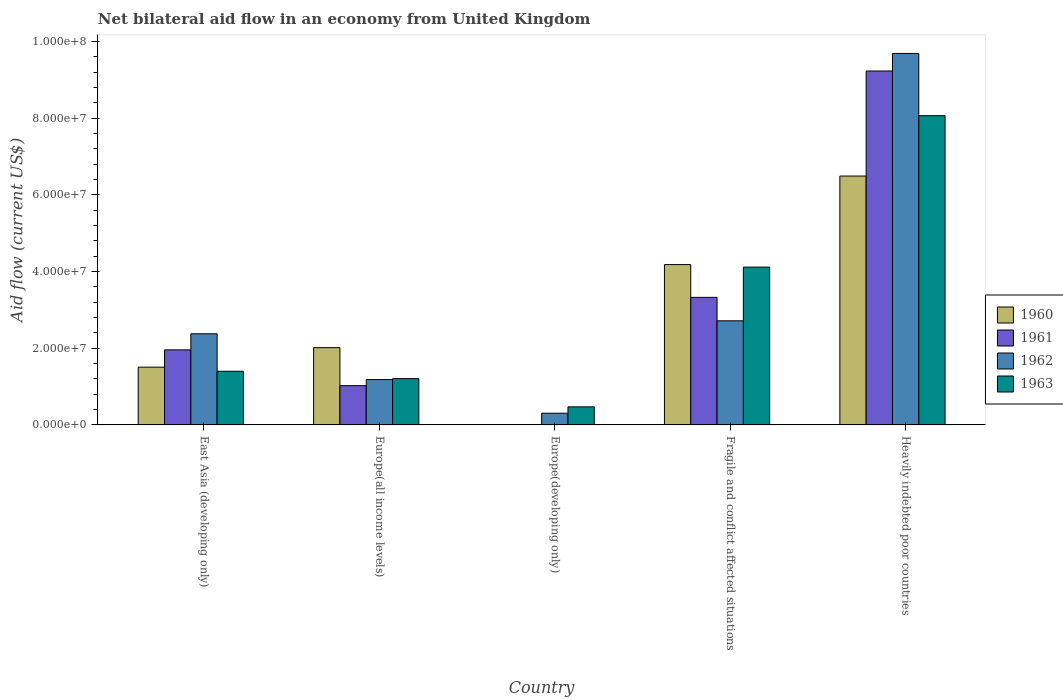How many groups of bars are there?
Your response must be concise. 5. Are the number of bars per tick equal to the number of legend labels?
Offer a terse response. No. Are the number of bars on each tick of the X-axis equal?
Provide a succinct answer. No. How many bars are there on the 1st tick from the left?
Offer a terse response. 4. How many bars are there on the 2nd tick from the right?
Provide a succinct answer. 4. What is the label of the 5th group of bars from the left?
Provide a short and direct response. Heavily indebted poor countries. In how many cases, is the number of bars for a given country not equal to the number of legend labels?
Your answer should be very brief. 1. What is the net bilateral aid flow in 1961 in Europe(developing only)?
Your answer should be compact. 0. Across all countries, what is the maximum net bilateral aid flow in 1962?
Keep it short and to the point. 9.69e+07. Across all countries, what is the minimum net bilateral aid flow in 1963?
Provide a succinct answer. 4.71e+06. In which country was the net bilateral aid flow in 1962 maximum?
Provide a short and direct response. Heavily indebted poor countries. What is the total net bilateral aid flow in 1962 in the graph?
Give a very brief answer. 1.63e+08. What is the difference between the net bilateral aid flow in 1963 in Europe(all income levels) and that in Heavily indebted poor countries?
Make the answer very short. -6.86e+07. What is the difference between the net bilateral aid flow in 1963 in East Asia (developing only) and the net bilateral aid flow in 1960 in Europe(developing only)?
Offer a very short reply. 1.40e+07. What is the average net bilateral aid flow in 1961 per country?
Your response must be concise. 3.11e+07. What is the difference between the net bilateral aid flow of/in 1961 and net bilateral aid flow of/in 1960 in East Asia (developing only)?
Your answer should be very brief. 4.51e+06. In how many countries, is the net bilateral aid flow in 1960 greater than 76000000 US$?
Offer a very short reply. 0. What is the ratio of the net bilateral aid flow in 1962 in East Asia (developing only) to that in Europe(all income levels)?
Your answer should be very brief. 2.01. What is the difference between the highest and the second highest net bilateral aid flow in 1962?
Offer a terse response. 7.31e+07. What is the difference between the highest and the lowest net bilateral aid flow in 1962?
Make the answer very short. 9.38e+07. In how many countries, is the net bilateral aid flow in 1960 greater than the average net bilateral aid flow in 1960 taken over all countries?
Provide a short and direct response. 2. Is it the case that in every country, the sum of the net bilateral aid flow in 1963 and net bilateral aid flow in 1962 is greater than the sum of net bilateral aid flow in 1961 and net bilateral aid flow in 1960?
Your response must be concise. No. How many countries are there in the graph?
Provide a short and direct response. 5. Are the values on the major ticks of Y-axis written in scientific E-notation?
Make the answer very short. Yes. Does the graph contain grids?
Make the answer very short. No. Where does the legend appear in the graph?
Give a very brief answer. Center right. What is the title of the graph?
Ensure brevity in your answer.  Net bilateral aid flow in an economy from United Kingdom. Does "1999" appear as one of the legend labels in the graph?
Offer a terse response. No. What is the Aid flow (current US$) in 1960 in East Asia (developing only)?
Keep it short and to the point. 1.51e+07. What is the Aid flow (current US$) of 1961 in East Asia (developing only)?
Keep it short and to the point. 1.96e+07. What is the Aid flow (current US$) in 1962 in East Asia (developing only)?
Provide a succinct answer. 2.38e+07. What is the Aid flow (current US$) in 1963 in East Asia (developing only)?
Your response must be concise. 1.40e+07. What is the Aid flow (current US$) of 1960 in Europe(all income levels)?
Keep it short and to the point. 2.02e+07. What is the Aid flow (current US$) of 1961 in Europe(all income levels)?
Make the answer very short. 1.02e+07. What is the Aid flow (current US$) in 1962 in Europe(all income levels)?
Provide a succinct answer. 1.18e+07. What is the Aid flow (current US$) in 1963 in Europe(all income levels)?
Offer a terse response. 1.21e+07. What is the Aid flow (current US$) in 1960 in Europe(developing only)?
Your answer should be very brief. 0. What is the Aid flow (current US$) of 1961 in Europe(developing only)?
Your response must be concise. 0. What is the Aid flow (current US$) in 1962 in Europe(developing only)?
Make the answer very short. 3.05e+06. What is the Aid flow (current US$) of 1963 in Europe(developing only)?
Ensure brevity in your answer.  4.71e+06. What is the Aid flow (current US$) in 1960 in Fragile and conflict affected situations?
Keep it short and to the point. 4.18e+07. What is the Aid flow (current US$) in 1961 in Fragile and conflict affected situations?
Keep it short and to the point. 3.33e+07. What is the Aid flow (current US$) in 1962 in Fragile and conflict affected situations?
Make the answer very short. 2.72e+07. What is the Aid flow (current US$) in 1963 in Fragile and conflict affected situations?
Offer a very short reply. 4.12e+07. What is the Aid flow (current US$) in 1960 in Heavily indebted poor countries?
Keep it short and to the point. 6.49e+07. What is the Aid flow (current US$) of 1961 in Heavily indebted poor countries?
Offer a terse response. 9.23e+07. What is the Aid flow (current US$) of 1962 in Heavily indebted poor countries?
Ensure brevity in your answer.  9.69e+07. What is the Aid flow (current US$) in 1963 in Heavily indebted poor countries?
Your response must be concise. 8.06e+07. Across all countries, what is the maximum Aid flow (current US$) of 1960?
Offer a very short reply. 6.49e+07. Across all countries, what is the maximum Aid flow (current US$) of 1961?
Provide a succinct answer. 9.23e+07. Across all countries, what is the maximum Aid flow (current US$) of 1962?
Your answer should be very brief. 9.69e+07. Across all countries, what is the maximum Aid flow (current US$) of 1963?
Offer a terse response. 8.06e+07. Across all countries, what is the minimum Aid flow (current US$) in 1962?
Your answer should be very brief. 3.05e+06. Across all countries, what is the minimum Aid flow (current US$) in 1963?
Keep it short and to the point. 4.71e+06. What is the total Aid flow (current US$) of 1960 in the graph?
Provide a short and direct response. 1.42e+08. What is the total Aid flow (current US$) of 1961 in the graph?
Ensure brevity in your answer.  1.55e+08. What is the total Aid flow (current US$) of 1962 in the graph?
Give a very brief answer. 1.63e+08. What is the total Aid flow (current US$) of 1963 in the graph?
Offer a terse response. 1.53e+08. What is the difference between the Aid flow (current US$) in 1960 in East Asia (developing only) and that in Europe(all income levels)?
Provide a succinct answer. -5.09e+06. What is the difference between the Aid flow (current US$) of 1961 in East Asia (developing only) and that in Europe(all income levels)?
Keep it short and to the point. 9.33e+06. What is the difference between the Aid flow (current US$) in 1962 in East Asia (developing only) and that in Europe(all income levels)?
Offer a very short reply. 1.19e+07. What is the difference between the Aid flow (current US$) in 1963 in East Asia (developing only) and that in Europe(all income levels)?
Make the answer very short. 1.92e+06. What is the difference between the Aid flow (current US$) in 1962 in East Asia (developing only) and that in Europe(developing only)?
Your response must be concise. 2.07e+07. What is the difference between the Aid flow (current US$) in 1963 in East Asia (developing only) and that in Europe(developing only)?
Your answer should be very brief. 9.28e+06. What is the difference between the Aid flow (current US$) of 1960 in East Asia (developing only) and that in Fragile and conflict affected situations?
Keep it short and to the point. -2.68e+07. What is the difference between the Aid flow (current US$) in 1961 in East Asia (developing only) and that in Fragile and conflict affected situations?
Provide a succinct answer. -1.37e+07. What is the difference between the Aid flow (current US$) of 1962 in East Asia (developing only) and that in Fragile and conflict affected situations?
Your answer should be very brief. -3.39e+06. What is the difference between the Aid flow (current US$) in 1963 in East Asia (developing only) and that in Fragile and conflict affected situations?
Provide a succinct answer. -2.72e+07. What is the difference between the Aid flow (current US$) of 1960 in East Asia (developing only) and that in Heavily indebted poor countries?
Your answer should be compact. -4.98e+07. What is the difference between the Aid flow (current US$) of 1961 in East Asia (developing only) and that in Heavily indebted poor countries?
Provide a succinct answer. -7.27e+07. What is the difference between the Aid flow (current US$) in 1962 in East Asia (developing only) and that in Heavily indebted poor countries?
Your answer should be very brief. -7.31e+07. What is the difference between the Aid flow (current US$) in 1963 in East Asia (developing only) and that in Heavily indebted poor countries?
Provide a succinct answer. -6.66e+07. What is the difference between the Aid flow (current US$) in 1962 in Europe(all income levels) and that in Europe(developing only)?
Offer a very short reply. 8.77e+06. What is the difference between the Aid flow (current US$) of 1963 in Europe(all income levels) and that in Europe(developing only)?
Ensure brevity in your answer.  7.36e+06. What is the difference between the Aid flow (current US$) of 1960 in Europe(all income levels) and that in Fragile and conflict affected situations?
Offer a very short reply. -2.17e+07. What is the difference between the Aid flow (current US$) in 1961 in Europe(all income levels) and that in Fragile and conflict affected situations?
Your response must be concise. -2.30e+07. What is the difference between the Aid flow (current US$) in 1962 in Europe(all income levels) and that in Fragile and conflict affected situations?
Offer a very short reply. -1.53e+07. What is the difference between the Aid flow (current US$) in 1963 in Europe(all income levels) and that in Fragile and conflict affected situations?
Provide a short and direct response. -2.91e+07. What is the difference between the Aid flow (current US$) of 1960 in Europe(all income levels) and that in Heavily indebted poor countries?
Your response must be concise. -4.48e+07. What is the difference between the Aid flow (current US$) in 1961 in Europe(all income levels) and that in Heavily indebted poor countries?
Ensure brevity in your answer.  -8.20e+07. What is the difference between the Aid flow (current US$) in 1962 in Europe(all income levels) and that in Heavily indebted poor countries?
Offer a very short reply. -8.50e+07. What is the difference between the Aid flow (current US$) in 1963 in Europe(all income levels) and that in Heavily indebted poor countries?
Your response must be concise. -6.86e+07. What is the difference between the Aid flow (current US$) of 1962 in Europe(developing only) and that in Fragile and conflict affected situations?
Ensure brevity in your answer.  -2.41e+07. What is the difference between the Aid flow (current US$) of 1963 in Europe(developing only) and that in Fragile and conflict affected situations?
Ensure brevity in your answer.  -3.64e+07. What is the difference between the Aid flow (current US$) in 1962 in Europe(developing only) and that in Heavily indebted poor countries?
Your answer should be very brief. -9.38e+07. What is the difference between the Aid flow (current US$) of 1963 in Europe(developing only) and that in Heavily indebted poor countries?
Provide a short and direct response. -7.59e+07. What is the difference between the Aid flow (current US$) in 1960 in Fragile and conflict affected situations and that in Heavily indebted poor countries?
Make the answer very short. -2.31e+07. What is the difference between the Aid flow (current US$) in 1961 in Fragile and conflict affected situations and that in Heavily indebted poor countries?
Ensure brevity in your answer.  -5.90e+07. What is the difference between the Aid flow (current US$) in 1962 in Fragile and conflict affected situations and that in Heavily indebted poor countries?
Provide a succinct answer. -6.97e+07. What is the difference between the Aid flow (current US$) of 1963 in Fragile and conflict affected situations and that in Heavily indebted poor countries?
Make the answer very short. -3.95e+07. What is the difference between the Aid flow (current US$) in 1960 in East Asia (developing only) and the Aid flow (current US$) in 1961 in Europe(all income levels)?
Make the answer very short. 4.82e+06. What is the difference between the Aid flow (current US$) of 1960 in East Asia (developing only) and the Aid flow (current US$) of 1962 in Europe(all income levels)?
Offer a terse response. 3.24e+06. What is the difference between the Aid flow (current US$) in 1960 in East Asia (developing only) and the Aid flow (current US$) in 1963 in Europe(all income levels)?
Provide a succinct answer. 2.99e+06. What is the difference between the Aid flow (current US$) in 1961 in East Asia (developing only) and the Aid flow (current US$) in 1962 in Europe(all income levels)?
Your answer should be compact. 7.75e+06. What is the difference between the Aid flow (current US$) in 1961 in East Asia (developing only) and the Aid flow (current US$) in 1963 in Europe(all income levels)?
Provide a short and direct response. 7.50e+06. What is the difference between the Aid flow (current US$) in 1962 in East Asia (developing only) and the Aid flow (current US$) in 1963 in Europe(all income levels)?
Ensure brevity in your answer.  1.17e+07. What is the difference between the Aid flow (current US$) of 1960 in East Asia (developing only) and the Aid flow (current US$) of 1962 in Europe(developing only)?
Ensure brevity in your answer.  1.20e+07. What is the difference between the Aid flow (current US$) of 1960 in East Asia (developing only) and the Aid flow (current US$) of 1963 in Europe(developing only)?
Your response must be concise. 1.04e+07. What is the difference between the Aid flow (current US$) in 1961 in East Asia (developing only) and the Aid flow (current US$) in 1962 in Europe(developing only)?
Provide a succinct answer. 1.65e+07. What is the difference between the Aid flow (current US$) in 1961 in East Asia (developing only) and the Aid flow (current US$) in 1963 in Europe(developing only)?
Give a very brief answer. 1.49e+07. What is the difference between the Aid flow (current US$) of 1962 in East Asia (developing only) and the Aid flow (current US$) of 1963 in Europe(developing only)?
Provide a succinct answer. 1.90e+07. What is the difference between the Aid flow (current US$) in 1960 in East Asia (developing only) and the Aid flow (current US$) in 1961 in Fragile and conflict affected situations?
Ensure brevity in your answer.  -1.82e+07. What is the difference between the Aid flow (current US$) in 1960 in East Asia (developing only) and the Aid flow (current US$) in 1962 in Fragile and conflict affected situations?
Provide a short and direct response. -1.21e+07. What is the difference between the Aid flow (current US$) in 1960 in East Asia (developing only) and the Aid flow (current US$) in 1963 in Fragile and conflict affected situations?
Your answer should be very brief. -2.61e+07. What is the difference between the Aid flow (current US$) in 1961 in East Asia (developing only) and the Aid flow (current US$) in 1962 in Fragile and conflict affected situations?
Offer a very short reply. -7.58e+06. What is the difference between the Aid flow (current US$) of 1961 in East Asia (developing only) and the Aid flow (current US$) of 1963 in Fragile and conflict affected situations?
Make the answer very short. -2.16e+07. What is the difference between the Aid flow (current US$) of 1962 in East Asia (developing only) and the Aid flow (current US$) of 1963 in Fragile and conflict affected situations?
Offer a very short reply. -1.74e+07. What is the difference between the Aid flow (current US$) of 1960 in East Asia (developing only) and the Aid flow (current US$) of 1961 in Heavily indebted poor countries?
Give a very brief answer. -7.72e+07. What is the difference between the Aid flow (current US$) in 1960 in East Asia (developing only) and the Aid flow (current US$) in 1962 in Heavily indebted poor countries?
Offer a very short reply. -8.18e+07. What is the difference between the Aid flow (current US$) in 1960 in East Asia (developing only) and the Aid flow (current US$) in 1963 in Heavily indebted poor countries?
Ensure brevity in your answer.  -6.56e+07. What is the difference between the Aid flow (current US$) in 1961 in East Asia (developing only) and the Aid flow (current US$) in 1962 in Heavily indebted poor countries?
Make the answer very short. -7.73e+07. What is the difference between the Aid flow (current US$) of 1961 in East Asia (developing only) and the Aid flow (current US$) of 1963 in Heavily indebted poor countries?
Offer a very short reply. -6.11e+07. What is the difference between the Aid flow (current US$) of 1962 in East Asia (developing only) and the Aid flow (current US$) of 1963 in Heavily indebted poor countries?
Offer a very short reply. -5.69e+07. What is the difference between the Aid flow (current US$) in 1960 in Europe(all income levels) and the Aid flow (current US$) in 1962 in Europe(developing only)?
Your answer should be very brief. 1.71e+07. What is the difference between the Aid flow (current US$) of 1960 in Europe(all income levels) and the Aid flow (current US$) of 1963 in Europe(developing only)?
Ensure brevity in your answer.  1.54e+07. What is the difference between the Aid flow (current US$) of 1961 in Europe(all income levels) and the Aid flow (current US$) of 1962 in Europe(developing only)?
Your answer should be very brief. 7.19e+06. What is the difference between the Aid flow (current US$) of 1961 in Europe(all income levels) and the Aid flow (current US$) of 1963 in Europe(developing only)?
Give a very brief answer. 5.53e+06. What is the difference between the Aid flow (current US$) of 1962 in Europe(all income levels) and the Aid flow (current US$) of 1963 in Europe(developing only)?
Offer a very short reply. 7.11e+06. What is the difference between the Aid flow (current US$) of 1960 in Europe(all income levels) and the Aid flow (current US$) of 1961 in Fragile and conflict affected situations?
Provide a short and direct response. -1.31e+07. What is the difference between the Aid flow (current US$) in 1960 in Europe(all income levels) and the Aid flow (current US$) in 1962 in Fragile and conflict affected situations?
Your answer should be compact. -7.00e+06. What is the difference between the Aid flow (current US$) in 1960 in Europe(all income levels) and the Aid flow (current US$) in 1963 in Fragile and conflict affected situations?
Provide a short and direct response. -2.10e+07. What is the difference between the Aid flow (current US$) of 1961 in Europe(all income levels) and the Aid flow (current US$) of 1962 in Fragile and conflict affected situations?
Provide a short and direct response. -1.69e+07. What is the difference between the Aid flow (current US$) of 1961 in Europe(all income levels) and the Aid flow (current US$) of 1963 in Fragile and conflict affected situations?
Give a very brief answer. -3.09e+07. What is the difference between the Aid flow (current US$) of 1962 in Europe(all income levels) and the Aid flow (current US$) of 1963 in Fragile and conflict affected situations?
Your answer should be compact. -2.93e+07. What is the difference between the Aid flow (current US$) in 1960 in Europe(all income levels) and the Aid flow (current US$) in 1961 in Heavily indebted poor countries?
Provide a succinct answer. -7.21e+07. What is the difference between the Aid flow (current US$) of 1960 in Europe(all income levels) and the Aid flow (current US$) of 1962 in Heavily indebted poor countries?
Your answer should be compact. -7.67e+07. What is the difference between the Aid flow (current US$) in 1960 in Europe(all income levels) and the Aid flow (current US$) in 1963 in Heavily indebted poor countries?
Offer a terse response. -6.05e+07. What is the difference between the Aid flow (current US$) in 1961 in Europe(all income levels) and the Aid flow (current US$) in 1962 in Heavily indebted poor countries?
Your answer should be compact. -8.66e+07. What is the difference between the Aid flow (current US$) of 1961 in Europe(all income levels) and the Aid flow (current US$) of 1963 in Heavily indebted poor countries?
Make the answer very short. -7.04e+07. What is the difference between the Aid flow (current US$) in 1962 in Europe(all income levels) and the Aid flow (current US$) in 1963 in Heavily indebted poor countries?
Ensure brevity in your answer.  -6.88e+07. What is the difference between the Aid flow (current US$) in 1962 in Europe(developing only) and the Aid flow (current US$) in 1963 in Fragile and conflict affected situations?
Provide a succinct answer. -3.81e+07. What is the difference between the Aid flow (current US$) in 1962 in Europe(developing only) and the Aid flow (current US$) in 1963 in Heavily indebted poor countries?
Provide a succinct answer. -7.76e+07. What is the difference between the Aid flow (current US$) in 1960 in Fragile and conflict affected situations and the Aid flow (current US$) in 1961 in Heavily indebted poor countries?
Offer a terse response. -5.05e+07. What is the difference between the Aid flow (current US$) in 1960 in Fragile and conflict affected situations and the Aid flow (current US$) in 1962 in Heavily indebted poor countries?
Ensure brevity in your answer.  -5.51e+07. What is the difference between the Aid flow (current US$) in 1960 in Fragile and conflict affected situations and the Aid flow (current US$) in 1963 in Heavily indebted poor countries?
Provide a succinct answer. -3.88e+07. What is the difference between the Aid flow (current US$) of 1961 in Fragile and conflict affected situations and the Aid flow (current US$) of 1962 in Heavily indebted poor countries?
Keep it short and to the point. -6.36e+07. What is the difference between the Aid flow (current US$) in 1961 in Fragile and conflict affected situations and the Aid flow (current US$) in 1963 in Heavily indebted poor countries?
Your answer should be very brief. -4.74e+07. What is the difference between the Aid flow (current US$) of 1962 in Fragile and conflict affected situations and the Aid flow (current US$) of 1963 in Heavily indebted poor countries?
Ensure brevity in your answer.  -5.35e+07. What is the average Aid flow (current US$) in 1960 per country?
Keep it short and to the point. 2.84e+07. What is the average Aid flow (current US$) in 1961 per country?
Your response must be concise. 3.11e+07. What is the average Aid flow (current US$) in 1962 per country?
Your response must be concise. 3.25e+07. What is the average Aid flow (current US$) in 1963 per country?
Keep it short and to the point. 3.05e+07. What is the difference between the Aid flow (current US$) in 1960 and Aid flow (current US$) in 1961 in East Asia (developing only)?
Give a very brief answer. -4.51e+06. What is the difference between the Aid flow (current US$) of 1960 and Aid flow (current US$) of 1962 in East Asia (developing only)?
Make the answer very short. -8.70e+06. What is the difference between the Aid flow (current US$) of 1960 and Aid flow (current US$) of 1963 in East Asia (developing only)?
Provide a short and direct response. 1.07e+06. What is the difference between the Aid flow (current US$) in 1961 and Aid flow (current US$) in 1962 in East Asia (developing only)?
Your answer should be very brief. -4.19e+06. What is the difference between the Aid flow (current US$) in 1961 and Aid flow (current US$) in 1963 in East Asia (developing only)?
Offer a terse response. 5.58e+06. What is the difference between the Aid flow (current US$) in 1962 and Aid flow (current US$) in 1963 in East Asia (developing only)?
Your response must be concise. 9.77e+06. What is the difference between the Aid flow (current US$) in 1960 and Aid flow (current US$) in 1961 in Europe(all income levels)?
Give a very brief answer. 9.91e+06. What is the difference between the Aid flow (current US$) of 1960 and Aid flow (current US$) of 1962 in Europe(all income levels)?
Your answer should be compact. 8.33e+06. What is the difference between the Aid flow (current US$) in 1960 and Aid flow (current US$) in 1963 in Europe(all income levels)?
Provide a short and direct response. 8.08e+06. What is the difference between the Aid flow (current US$) in 1961 and Aid flow (current US$) in 1962 in Europe(all income levels)?
Provide a short and direct response. -1.58e+06. What is the difference between the Aid flow (current US$) of 1961 and Aid flow (current US$) of 1963 in Europe(all income levels)?
Make the answer very short. -1.83e+06. What is the difference between the Aid flow (current US$) in 1962 and Aid flow (current US$) in 1963 in Europe(all income levels)?
Provide a short and direct response. -2.50e+05. What is the difference between the Aid flow (current US$) of 1962 and Aid flow (current US$) of 1963 in Europe(developing only)?
Your answer should be compact. -1.66e+06. What is the difference between the Aid flow (current US$) of 1960 and Aid flow (current US$) of 1961 in Fragile and conflict affected situations?
Offer a very short reply. 8.55e+06. What is the difference between the Aid flow (current US$) of 1960 and Aid flow (current US$) of 1962 in Fragile and conflict affected situations?
Ensure brevity in your answer.  1.47e+07. What is the difference between the Aid flow (current US$) in 1961 and Aid flow (current US$) in 1962 in Fragile and conflict affected situations?
Your answer should be very brief. 6.11e+06. What is the difference between the Aid flow (current US$) in 1961 and Aid flow (current US$) in 1963 in Fragile and conflict affected situations?
Provide a succinct answer. -7.89e+06. What is the difference between the Aid flow (current US$) of 1962 and Aid flow (current US$) of 1963 in Fragile and conflict affected situations?
Offer a very short reply. -1.40e+07. What is the difference between the Aid flow (current US$) of 1960 and Aid flow (current US$) of 1961 in Heavily indebted poor countries?
Your answer should be compact. -2.74e+07. What is the difference between the Aid flow (current US$) in 1960 and Aid flow (current US$) in 1962 in Heavily indebted poor countries?
Keep it short and to the point. -3.20e+07. What is the difference between the Aid flow (current US$) in 1960 and Aid flow (current US$) in 1963 in Heavily indebted poor countries?
Offer a terse response. -1.57e+07. What is the difference between the Aid flow (current US$) of 1961 and Aid flow (current US$) of 1962 in Heavily indebted poor countries?
Ensure brevity in your answer.  -4.58e+06. What is the difference between the Aid flow (current US$) of 1961 and Aid flow (current US$) of 1963 in Heavily indebted poor countries?
Make the answer very short. 1.16e+07. What is the difference between the Aid flow (current US$) in 1962 and Aid flow (current US$) in 1963 in Heavily indebted poor countries?
Offer a terse response. 1.62e+07. What is the ratio of the Aid flow (current US$) in 1960 in East Asia (developing only) to that in Europe(all income levels)?
Make the answer very short. 0.75. What is the ratio of the Aid flow (current US$) in 1961 in East Asia (developing only) to that in Europe(all income levels)?
Your response must be concise. 1.91. What is the ratio of the Aid flow (current US$) in 1962 in East Asia (developing only) to that in Europe(all income levels)?
Offer a terse response. 2.01. What is the ratio of the Aid flow (current US$) of 1963 in East Asia (developing only) to that in Europe(all income levels)?
Provide a short and direct response. 1.16. What is the ratio of the Aid flow (current US$) of 1962 in East Asia (developing only) to that in Europe(developing only)?
Your answer should be compact. 7.79. What is the ratio of the Aid flow (current US$) of 1963 in East Asia (developing only) to that in Europe(developing only)?
Offer a very short reply. 2.97. What is the ratio of the Aid flow (current US$) of 1960 in East Asia (developing only) to that in Fragile and conflict affected situations?
Your answer should be compact. 0.36. What is the ratio of the Aid flow (current US$) of 1961 in East Asia (developing only) to that in Fragile and conflict affected situations?
Your response must be concise. 0.59. What is the ratio of the Aid flow (current US$) of 1962 in East Asia (developing only) to that in Fragile and conflict affected situations?
Provide a short and direct response. 0.88. What is the ratio of the Aid flow (current US$) of 1963 in East Asia (developing only) to that in Fragile and conflict affected situations?
Your response must be concise. 0.34. What is the ratio of the Aid flow (current US$) in 1960 in East Asia (developing only) to that in Heavily indebted poor countries?
Provide a short and direct response. 0.23. What is the ratio of the Aid flow (current US$) of 1961 in East Asia (developing only) to that in Heavily indebted poor countries?
Provide a succinct answer. 0.21. What is the ratio of the Aid flow (current US$) of 1962 in East Asia (developing only) to that in Heavily indebted poor countries?
Give a very brief answer. 0.25. What is the ratio of the Aid flow (current US$) in 1963 in East Asia (developing only) to that in Heavily indebted poor countries?
Offer a terse response. 0.17. What is the ratio of the Aid flow (current US$) in 1962 in Europe(all income levels) to that in Europe(developing only)?
Offer a very short reply. 3.88. What is the ratio of the Aid flow (current US$) in 1963 in Europe(all income levels) to that in Europe(developing only)?
Provide a succinct answer. 2.56. What is the ratio of the Aid flow (current US$) of 1960 in Europe(all income levels) to that in Fragile and conflict affected situations?
Make the answer very short. 0.48. What is the ratio of the Aid flow (current US$) of 1961 in Europe(all income levels) to that in Fragile and conflict affected situations?
Provide a short and direct response. 0.31. What is the ratio of the Aid flow (current US$) of 1962 in Europe(all income levels) to that in Fragile and conflict affected situations?
Your answer should be compact. 0.44. What is the ratio of the Aid flow (current US$) in 1963 in Europe(all income levels) to that in Fragile and conflict affected situations?
Make the answer very short. 0.29. What is the ratio of the Aid flow (current US$) in 1960 in Europe(all income levels) to that in Heavily indebted poor countries?
Your response must be concise. 0.31. What is the ratio of the Aid flow (current US$) in 1961 in Europe(all income levels) to that in Heavily indebted poor countries?
Give a very brief answer. 0.11. What is the ratio of the Aid flow (current US$) in 1962 in Europe(all income levels) to that in Heavily indebted poor countries?
Your answer should be very brief. 0.12. What is the ratio of the Aid flow (current US$) of 1963 in Europe(all income levels) to that in Heavily indebted poor countries?
Your response must be concise. 0.15. What is the ratio of the Aid flow (current US$) in 1962 in Europe(developing only) to that in Fragile and conflict affected situations?
Your answer should be very brief. 0.11. What is the ratio of the Aid flow (current US$) of 1963 in Europe(developing only) to that in Fragile and conflict affected situations?
Keep it short and to the point. 0.11. What is the ratio of the Aid flow (current US$) in 1962 in Europe(developing only) to that in Heavily indebted poor countries?
Provide a short and direct response. 0.03. What is the ratio of the Aid flow (current US$) of 1963 in Europe(developing only) to that in Heavily indebted poor countries?
Keep it short and to the point. 0.06. What is the ratio of the Aid flow (current US$) in 1960 in Fragile and conflict affected situations to that in Heavily indebted poor countries?
Make the answer very short. 0.64. What is the ratio of the Aid flow (current US$) in 1961 in Fragile and conflict affected situations to that in Heavily indebted poor countries?
Make the answer very short. 0.36. What is the ratio of the Aid flow (current US$) of 1962 in Fragile and conflict affected situations to that in Heavily indebted poor countries?
Provide a short and direct response. 0.28. What is the ratio of the Aid flow (current US$) in 1963 in Fragile and conflict affected situations to that in Heavily indebted poor countries?
Your response must be concise. 0.51. What is the difference between the highest and the second highest Aid flow (current US$) in 1960?
Your response must be concise. 2.31e+07. What is the difference between the highest and the second highest Aid flow (current US$) of 1961?
Provide a succinct answer. 5.90e+07. What is the difference between the highest and the second highest Aid flow (current US$) in 1962?
Offer a terse response. 6.97e+07. What is the difference between the highest and the second highest Aid flow (current US$) of 1963?
Offer a terse response. 3.95e+07. What is the difference between the highest and the lowest Aid flow (current US$) of 1960?
Your answer should be very brief. 6.49e+07. What is the difference between the highest and the lowest Aid flow (current US$) of 1961?
Keep it short and to the point. 9.23e+07. What is the difference between the highest and the lowest Aid flow (current US$) in 1962?
Ensure brevity in your answer.  9.38e+07. What is the difference between the highest and the lowest Aid flow (current US$) of 1963?
Offer a terse response. 7.59e+07. 